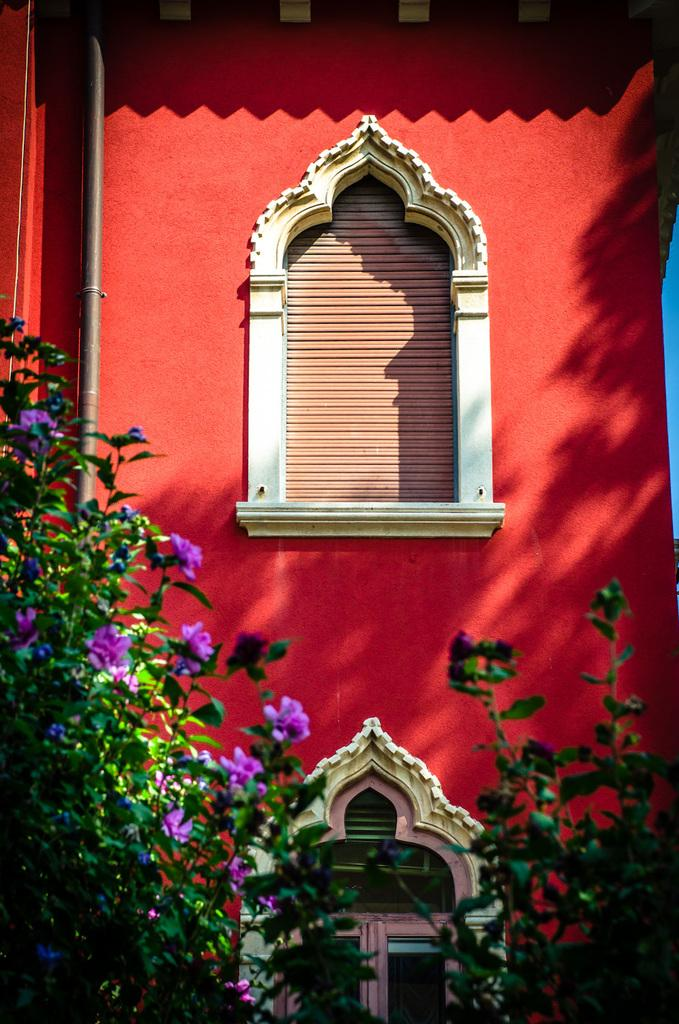What type of plants are in the front of the image? There are flower plants in the front of the image. What structure can be seen in the image? There is a building in the image. What is the color of the building? The building is red in color. What feature is present in the middle of the building? The building has a window in the middle. Can you hear any music coming from the building in the image? There is no information about music or any sound in the image, so it cannot be determined if music is coming from the building. How many bees are buzzing around the flower plants in the image? There are no bees visible in the image, so it cannot be determined how many bees are buzzing around the flower plants. 